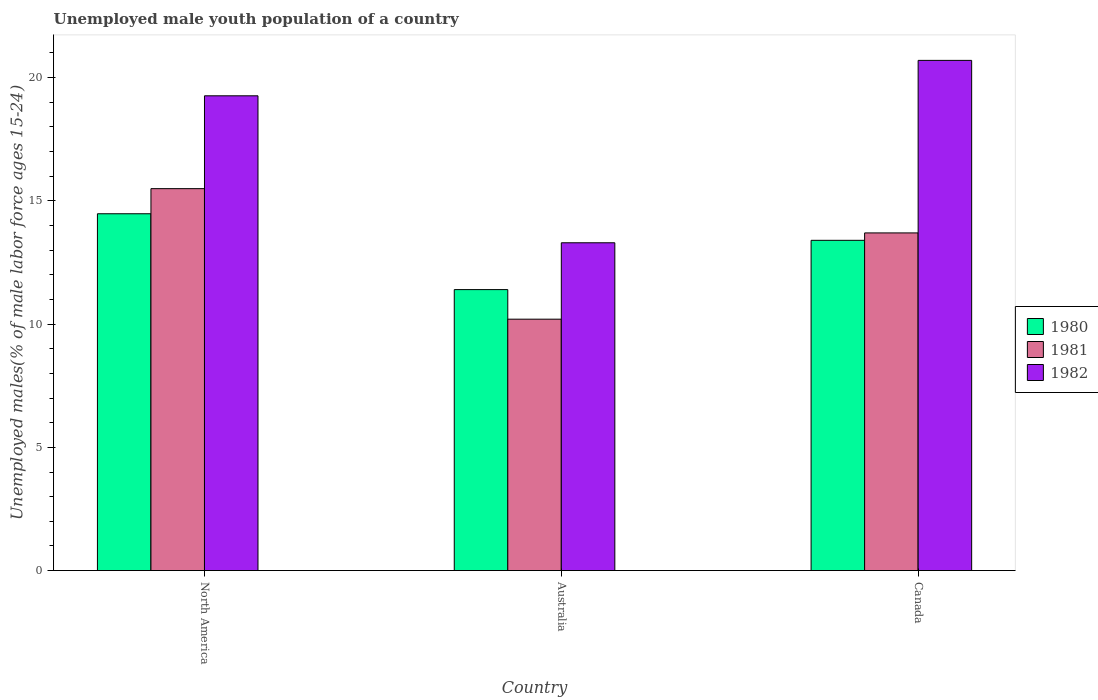Are the number of bars per tick equal to the number of legend labels?
Provide a short and direct response. Yes. Are the number of bars on each tick of the X-axis equal?
Ensure brevity in your answer.  Yes. What is the label of the 2nd group of bars from the left?
Your response must be concise. Australia. What is the percentage of unemployed male youth population in 1980 in North America?
Provide a short and direct response. 14.48. Across all countries, what is the maximum percentage of unemployed male youth population in 1980?
Give a very brief answer. 14.48. Across all countries, what is the minimum percentage of unemployed male youth population in 1981?
Your response must be concise. 10.2. In which country was the percentage of unemployed male youth population in 1981 maximum?
Keep it short and to the point. North America. What is the total percentage of unemployed male youth population in 1980 in the graph?
Offer a very short reply. 39.28. What is the difference between the percentage of unemployed male youth population in 1982 in Australia and that in North America?
Offer a very short reply. -5.96. What is the difference between the percentage of unemployed male youth population in 1981 in Canada and the percentage of unemployed male youth population in 1980 in North America?
Keep it short and to the point. -0.78. What is the average percentage of unemployed male youth population in 1981 per country?
Keep it short and to the point. 13.13. What is the difference between the percentage of unemployed male youth population of/in 1980 and percentage of unemployed male youth population of/in 1982 in North America?
Offer a very short reply. -4.79. In how many countries, is the percentage of unemployed male youth population in 1981 greater than 14 %?
Provide a succinct answer. 1. What is the ratio of the percentage of unemployed male youth population in 1981 in Australia to that in Canada?
Offer a very short reply. 0.74. Is the percentage of unemployed male youth population in 1982 in Canada less than that in North America?
Keep it short and to the point. No. What is the difference between the highest and the second highest percentage of unemployed male youth population in 1982?
Your answer should be compact. -1.44. What is the difference between the highest and the lowest percentage of unemployed male youth population in 1982?
Your answer should be very brief. 7.4. In how many countries, is the percentage of unemployed male youth population in 1981 greater than the average percentage of unemployed male youth population in 1981 taken over all countries?
Provide a succinct answer. 2. Is the sum of the percentage of unemployed male youth population in 1980 in Canada and North America greater than the maximum percentage of unemployed male youth population in 1982 across all countries?
Provide a succinct answer. Yes. What does the 3rd bar from the left in North America represents?
Offer a very short reply. 1982. What is the difference between two consecutive major ticks on the Y-axis?
Make the answer very short. 5. Are the values on the major ticks of Y-axis written in scientific E-notation?
Ensure brevity in your answer.  No. Does the graph contain grids?
Keep it short and to the point. No. How many legend labels are there?
Make the answer very short. 3. How are the legend labels stacked?
Ensure brevity in your answer.  Vertical. What is the title of the graph?
Offer a very short reply. Unemployed male youth population of a country. What is the label or title of the X-axis?
Offer a very short reply. Country. What is the label or title of the Y-axis?
Offer a very short reply. Unemployed males(% of male labor force ages 15-24). What is the Unemployed males(% of male labor force ages 15-24) of 1980 in North America?
Provide a short and direct response. 14.48. What is the Unemployed males(% of male labor force ages 15-24) in 1981 in North America?
Offer a terse response. 15.5. What is the Unemployed males(% of male labor force ages 15-24) in 1982 in North America?
Provide a short and direct response. 19.26. What is the Unemployed males(% of male labor force ages 15-24) of 1980 in Australia?
Your answer should be very brief. 11.4. What is the Unemployed males(% of male labor force ages 15-24) of 1981 in Australia?
Provide a short and direct response. 10.2. What is the Unemployed males(% of male labor force ages 15-24) in 1982 in Australia?
Keep it short and to the point. 13.3. What is the Unemployed males(% of male labor force ages 15-24) of 1980 in Canada?
Your answer should be compact. 13.4. What is the Unemployed males(% of male labor force ages 15-24) in 1981 in Canada?
Make the answer very short. 13.7. What is the Unemployed males(% of male labor force ages 15-24) in 1982 in Canada?
Your answer should be compact. 20.7. Across all countries, what is the maximum Unemployed males(% of male labor force ages 15-24) in 1980?
Make the answer very short. 14.48. Across all countries, what is the maximum Unemployed males(% of male labor force ages 15-24) in 1981?
Provide a succinct answer. 15.5. Across all countries, what is the maximum Unemployed males(% of male labor force ages 15-24) in 1982?
Offer a terse response. 20.7. Across all countries, what is the minimum Unemployed males(% of male labor force ages 15-24) in 1980?
Provide a succinct answer. 11.4. Across all countries, what is the minimum Unemployed males(% of male labor force ages 15-24) of 1981?
Keep it short and to the point. 10.2. Across all countries, what is the minimum Unemployed males(% of male labor force ages 15-24) in 1982?
Make the answer very short. 13.3. What is the total Unemployed males(% of male labor force ages 15-24) in 1980 in the graph?
Give a very brief answer. 39.28. What is the total Unemployed males(% of male labor force ages 15-24) of 1981 in the graph?
Offer a terse response. 39.4. What is the total Unemployed males(% of male labor force ages 15-24) of 1982 in the graph?
Provide a short and direct response. 53.26. What is the difference between the Unemployed males(% of male labor force ages 15-24) in 1980 in North America and that in Australia?
Keep it short and to the point. 3.08. What is the difference between the Unemployed males(% of male labor force ages 15-24) in 1981 in North America and that in Australia?
Make the answer very short. 5.3. What is the difference between the Unemployed males(% of male labor force ages 15-24) of 1982 in North America and that in Australia?
Provide a short and direct response. 5.96. What is the difference between the Unemployed males(% of male labor force ages 15-24) in 1980 in North America and that in Canada?
Provide a succinct answer. 1.08. What is the difference between the Unemployed males(% of male labor force ages 15-24) in 1981 in North America and that in Canada?
Offer a terse response. 1.8. What is the difference between the Unemployed males(% of male labor force ages 15-24) of 1982 in North America and that in Canada?
Provide a succinct answer. -1.44. What is the difference between the Unemployed males(% of male labor force ages 15-24) in 1982 in Australia and that in Canada?
Provide a succinct answer. -7.4. What is the difference between the Unemployed males(% of male labor force ages 15-24) in 1980 in North America and the Unemployed males(% of male labor force ages 15-24) in 1981 in Australia?
Offer a terse response. 4.28. What is the difference between the Unemployed males(% of male labor force ages 15-24) of 1980 in North America and the Unemployed males(% of male labor force ages 15-24) of 1982 in Australia?
Offer a terse response. 1.18. What is the difference between the Unemployed males(% of male labor force ages 15-24) in 1981 in North America and the Unemployed males(% of male labor force ages 15-24) in 1982 in Australia?
Provide a short and direct response. 2.2. What is the difference between the Unemployed males(% of male labor force ages 15-24) in 1980 in North America and the Unemployed males(% of male labor force ages 15-24) in 1981 in Canada?
Offer a terse response. 0.78. What is the difference between the Unemployed males(% of male labor force ages 15-24) in 1980 in North America and the Unemployed males(% of male labor force ages 15-24) in 1982 in Canada?
Ensure brevity in your answer.  -6.22. What is the difference between the Unemployed males(% of male labor force ages 15-24) in 1981 in North America and the Unemployed males(% of male labor force ages 15-24) in 1982 in Canada?
Your answer should be compact. -5.2. What is the difference between the Unemployed males(% of male labor force ages 15-24) in 1981 in Australia and the Unemployed males(% of male labor force ages 15-24) in 1982 in Canada?
Keep it short and to the point. -10.5. What is the average Unemployed males(% of male labor force ages 15-24) in 1980 per country?
Give a very brief answer. 13.09. What is the average Unemployed males(% of male labor force ages 15-24) of 1981 per country?
Offer a very short reply. 13.13. What is the average Unemployed males(% of male labor force ages 15-24) of 1982 per country?
Make the answer very short. 17.75. What is the difference between the Unemployed males(% of male labor force ages 15-24) of 1980 and Unemployed males(% of male labor force ages 15-24) of 1981 in North America?
Provide a succinct answer. -1.02. What is the difference between the Unemployed males(% of male labor force ages 15-24) of 1980 and Unemployed males(% of male labor force ages 15-24) of 1982 in North America?
Provide a short and direct response. -4.79. What is the difference between the Unemployed males(% of male labor force ages 15-24) of 1981 and Unemployed males(% of male labor force ages 15-24) of 1982 in North America?
Offer a very short reply. -3.77. What is the difference between the Unemployed males(% of male labor force ages 15-24) of 1980 and Unemployed males(% of male labor force ages 15-24) of 1982 in Australia?
Make the answer very short. -1.9. What is the difference between the Unemployed males(% of male labor force ages 15-24) of 1981 and Unemployed males(% of male labor force ages 15-24) of 1982 in Australia?
Provide a succinct answer. -3.1. What is the difference between the Unemployed males(% of male labor force ages 15-24) of 1980 and Unemployed males(% of male labor force ages 15-24) of 1982 in Canada?
Keep it short and to the point. -7.3. What is the ratio of the Unemployed males(% of male labor force ages 15-24) of 1980 in North America to that in Australia?
Ensure brevity in your answer.  1.27. What is the ratio of the Unemployed males(% of male labor force ages 15-24) of 1981 in North America to that in Australia?
Your answer should be very brief. 1.52. What is the ratio of the Unemployed males(% of male labor force ages 15-24) of 1982 in North America to that in Australia?
Provide a short and direct response. 1.45. What is the ratio of the Unemployed males(% of male labor force ages 15-24) in 1980 in North America to that in Canada?
Your answer should be compact. 1.08. What is the ratio of the Unemployed males(% of male labor force ages 15-24) of 1981 in North America to that in Canada?
Keep it short and to the point. 1.13. What is the ratio of the Unemployed males(% of male labor force ages 15-24) of 1982 in North America to that in Canada?
Your response must be concise. 0.93. What is the ratio of the Unemployed males(% of male labor force ages 15-24) in 1980 in Australia to that in Canada?
Keep it short and to the point. 0.85. What is the ratio of the Unemployed males(% of male labor force ages 15-24) of 1981 in Australia to that in Canada?
Keep it short and to the point. 0.74. What is the ratio of the Unemployed males(% of male labor force ages 15-24) of 1982 in Australia to that in Canada?
Provide a succinct answer. 0.64. What is the difference between the highest and the second highest Unemployed males(% of male labor force ages 15-24) in 1980?
Offer a terse response. 1.08. What is the difference between the highest and the second highest Unemployed males(% of male labor force ages 15-24) of 1981?
Keep it short and to the point. 1.8. What is the difference between the highest and the second highest Unemployed males(% of male labor force ages 15-24) of 1982?
Keep it short and to the point. 1.44. What is the difference between the highest and the lowest Unemployed males(% of male labor force ages 15-24) in 1980?
Keep it short and to the point. 3.08. What is the difference between the highest and the lowest Unemployed males(% of male labor force ages 15-24) of 1981?
Your answer should be compact. 5.3. 